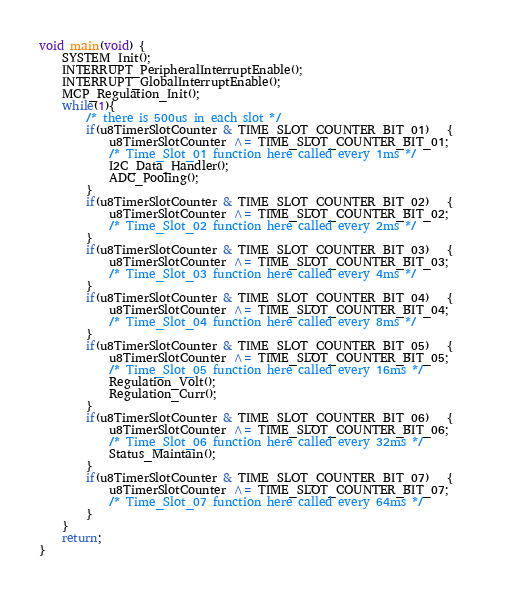Convert code to text. <code><loc_0><loc_0><loc_500><loc_500><_C_>void main(void) {
    SYSTEM_Init();
    INTERRUPT_PeripheralInterruptEnable();
    INTERRUPT_GlobalInterruptEnable();
    MCP_Regulation_Init();
    while(1){
        /* there is 500us in each slot */
        if(u8TimerSlotCounter & TIME_SLOT_COUNTER_BIT_01)   {
            u8TimerSlotCounter ^= TIME_SLOT_COUNTER_BIT_01;
            /* Time_Slot_01 function here called every 1ms */
            I2C_Data_Handler();
            ADC_Pooling();
        }
        if(u8TimerSlotCounter & TIME_SLOT_COUNTER_BIT_02)   {
            u8TimerSlotCounter ^= TIME_SLOT_COUNTER_BIT_02;
            /* Time_Slot_02 function here called every 2ms */            
        }
        if(u8TimerSlotCounter & TIME_SLOT_COUNTER_BIT_03)   {
            u8TimerSlotCounter ^= TIME_SLOT_COUNTER_BIT_03;
            /* Time_Slot_03 function here called every 4ms */
        }
        if(u8TimerSlotCounter & TIME_SLOT_COUNTER_BIT_04)   {
            u8TimerSlotCounter ^= TIME_SLOT_COUNTER_BIT_04;
            /* Time_Slot_04 function here called every 8ms */
        }
        if(u8TimerSlotCounter & TIME_SLOT_COUNTER_BIT_05)   {
            u8TimerSlotCounter ^= TIME_SLOT_COUNTER_BIT_05;
            /* Time_Slot_05 function here called every 16ms */
            Regulation_Volt();
            Regulation_Curr();
        }
        if(u8TimerSlotCounter & TIME_SLOT_COUNTER_BIT_06)   {
            u8TimerSlotCounter ^= TIME_SLOT_COUNTER_BIT_06;
            /* Time_Slot_06 function here called every 32ms */
            Status_Maintain();    
        }
        if(u8TimerSlotCounter & TIME_SLOT_COUNTER_BIT_07)   {
            u8TimerSlotCounter ^= TIME_SLOT_COUNTER_BIT_07;
            /* Time_Slot_07 function here called every 64ms */
        }
    }        
    return;
}
</code> 